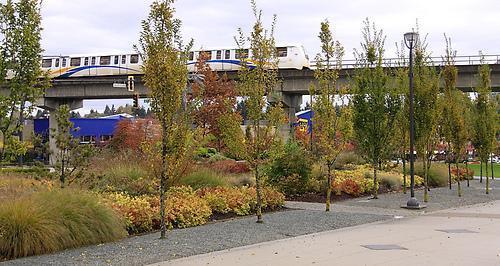How many trains are there?
Give a very brief answer. 1. 